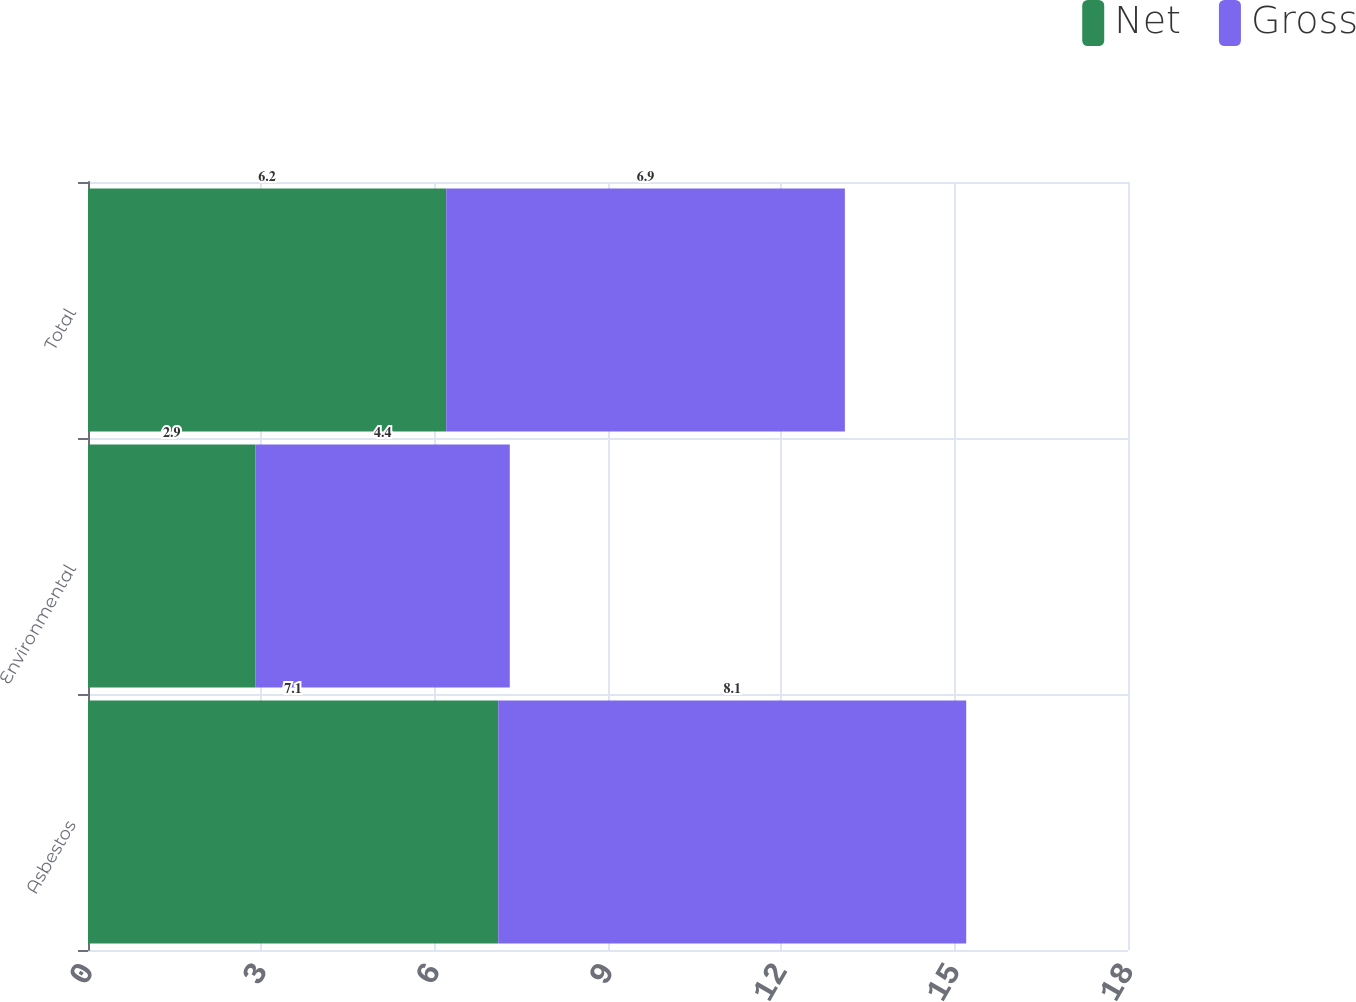<chart> <loc_0><loc_0><loc_500><loc_500><stacked_bar_chart><ecel><fcel>Asbestos<fcel>Environmental<fcel>Total<nl><fcel>Net<fcel>7.1<fcel>2.9<fcel>6.2<nl><fcel>Gross<fcel>8.1<fcel>4.4<fcel>6.9<nl></chart> 